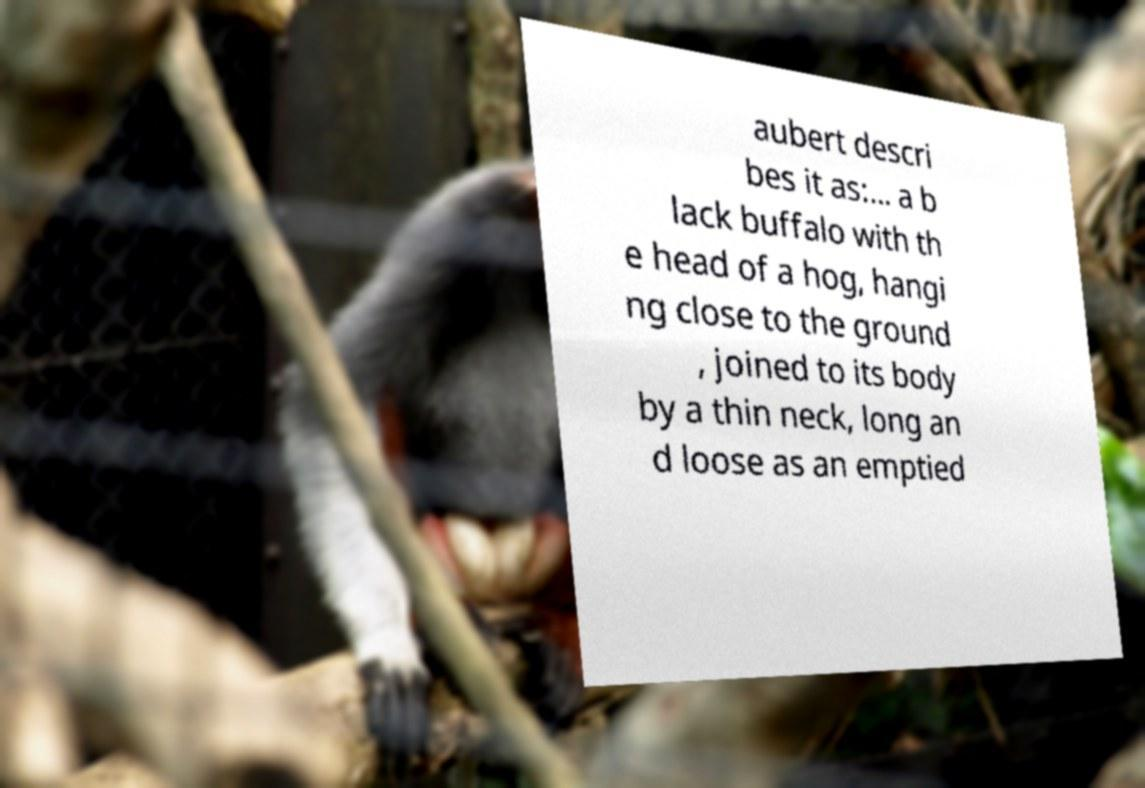What messages or text are displayed in this image? I need them in a readable, typed format. aubert descri bes it as:... a b lack buffalo with th e head of a hog, hangi ng close to the ground , joined to its body by a thin neck, long an d loose as an emptied 